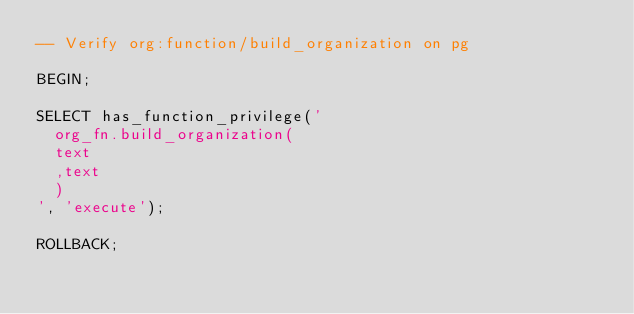<code> <loc_0><loc_0><loc_500><loc_500><_SQL_>-- Verify org:function/build_organization on pg

BEGIN;

SELECT has_function_privilege('
  org_fn.build_organization(
  text
  ,text
  )
', 'execute');

ROLLBACK;
</code> 